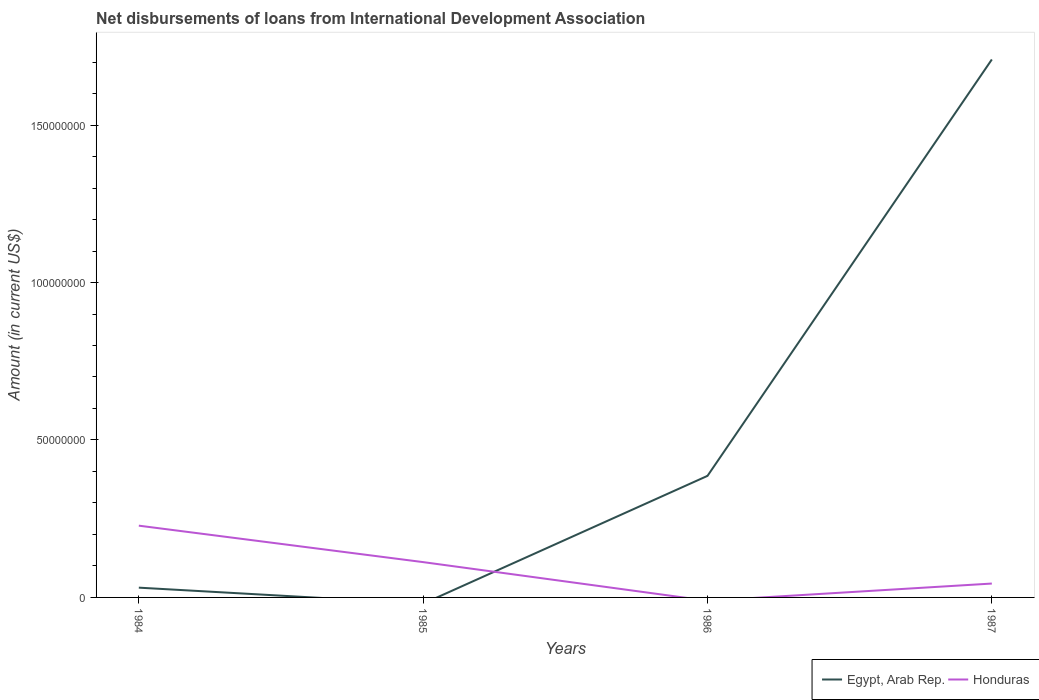How many different coloured lines are there?
Your response must be concise. 2. Does the line corresponding to Honduras intersect with the line corresponding to Egypt, Arab Rep.?
Offer a very short reply. Yes. Across all years, what is the maximum amount of loans disbursed in Honduras?
Ensure brevity in your answer.  0. What is the total amount of loans disbursed in Honduras in the graph?
Offer a terse response. 1.84e+07. What is the difference between the highest and the second highest amount of loans disbursed in Egypt, Arab Rep.?
Your answer should be compact. 1.71e+08. Is the amount of loans disbursed in Egypt, Arab Rep. strictly greater than the amount of loans disbursed in Honduras over the years?
Your answer should be compact. No. How many lines are there?
Make the answer very short. 2. How many years are there in the graph?
Keep it short and to the point. 4. What is the difference between two consecutive major ticks on the Y-axis?
Offer a terse response. 5.00e+07. Are the values on the major ticks of Y-axis written in scientific E-notation?
Keep it short and to the point. No. Does the graph contain grids?
Your response must be concise. No. Where does the legend appear in the graph?
Provide a short and direct response. Bottom right. What is the title of the graph?
Your response must be concise. Net disbursements of loans from International Development Association. What is the Amount (in current US$) in Egypt, Arab Rep. in 1984?
Your response must be concise. 3.10e+06. What is the Amount (in current US$) of Honduras in 1984?
Provide a short and direct response. 2.28e+07. What is the Amount (in current US$) of Honduras in 1985?
Give a very brief answer. 1.12e+07. What is the Amount (in current US$) in Egypt, Arab Rep. in 1986?
Provide a succinct answer. 3.86e+07. What is the Amount (in current US$) in Honduras in 1986?
Offer a very short reply. 0. What is the Amount (in current US$) in Egypt, Arab Rep. in 1987?
Offer a very short reply. 1.71e+08. What is the Amount (in current US$) of Honduras in 1987?
Your answer should be very brief. 4.41e+06. Across all years, what is the maximum Amount (in current US$) of Egypt, Arab Rep.?
Ensure brevity in your answer.  1.71e+08. Across all years, what is the maximum Amount (in current US$) of Honduras?
Make the answer very short. 2.28e+07. Across all years, what is the minimum Amount (in current US$) in Honduras?
Provide a succinct answer. 0. What is the total Amount (in current US$) in Egypt, Arab Rep. in the graph?
Keep it short and to the point. 2.13e+08. What is the total Amount (in current US$) of Honduras in the graph?
Offer a very short reply. 3.84e+07. What is the difference between the Amount (in current US$) in Honduras in 1984 and that in 1985?
Offer a very short reply. 1.16e+07. What is the difference between the Amount (in current US$) of Egypt, Arab Rep. in 1984 and that in 1986?
Give a very brief answer. -3.55e+07. What is the difference between the Amount (in current US$) of Egypt, Arab Rep. in 1984 and that in 1987?
Offer a terse response. -1.68e+08. What is the difference between the Amount (in current US$) in Honduras in 1984 and that in 1987?
Provide a succinct answer. 1.84e+07. What is the difference between the Amount (in current US$) in Honduras in 1985 and that in 1987?
Your answer should be compact. 6.81e+06. What is the difference between the Amount (in current US$) of Egypt, Arab Rep. in 1986 and that in 1987?
Your response must be concise. -1.32e+08. What is the difference between the Amount (in current US$) of Egypt, Arab Rep. in 1984 and the Amount (in current US$) of Honduras in 1985?
Keep it short and to the point. -8.11e+06. What is the difference between the Amount (in current US$) of Egypt, Arab Rep. in 1984 and the Amount (in current US$) of Honduras in 1987?
Make the answer very short. -1.30e+06. What is the difference between the Amount (in current US$) of Egypt, Arab Rep. in 1986 and the Amount (in current US$) of Honduras in 1987?
Give a very brief answer. 3.42e+07. What is the average Amount (in current US$) of Egypt, Arab Rep. per year?
Keep it short and to the point. 5.31e+07. What is the average Amount (in current US$) in Honduras per year?
Offer a very short reply. 9.60e+06. In the year 1984, what is the difference between the Amount (in current US$) of Egypt, Arab Rep. and Amount (in current US$) of Honduras?
Keep it short and to the point. -1.97e+07. In the year 1987, what is the difference between the Amount (in current US$) of Egypt, Arab Rep. and Amount (in current US$) of Honduras?
Keep it short and to the point. 1.66e+08. What is the ratio of the Amount (in current US$) in Honduras in 1984 to that in 1985?
Keep it short and to the point. 2.03. What is the ratio of the Amount (in current US$) of Egypt, Arab Rep. in 1984 to that in 1986?
Provide a succinct answer. 0.08. What is the ratio of the Amount (in current US$) in Egypt, Arab Rep. in 1984 to that in 1987?
Keep it short and to the point. 0.02. What is the ratio of the Amount (in current US$) of Honduras in 1984 to that in 1987?
Offer a very short reply. 5.17. What is the ratio of the Amount (in current US$) in Honduras in 1985 to that in 1987?
Offer a terse response. 2.54. What is the ratio of the Amount (in current US$) in Egypt, Arab Rep. in 1986 to that in 1987?
Provide a succinct answer. 0.23. What is the difference between the highest and the second highest Amount (in current US$) of Egypt, Arab Rep.?
Ensure brevity in your answer.  1.32e+08. What is the difference between the highest and the second highest Amount (in current US$) of Honduras?
Make the answer very short. 1.16e+07. What is the difference between the highest and the lowest Amount (in current US$) in Egypt, Arab Rep.?
Your response must be concise. 1.71e+08. What is the difference between the highest and the lowest Amount (in current US$) of Honduras?
Provide a succinct answer. 2.28e+07. 